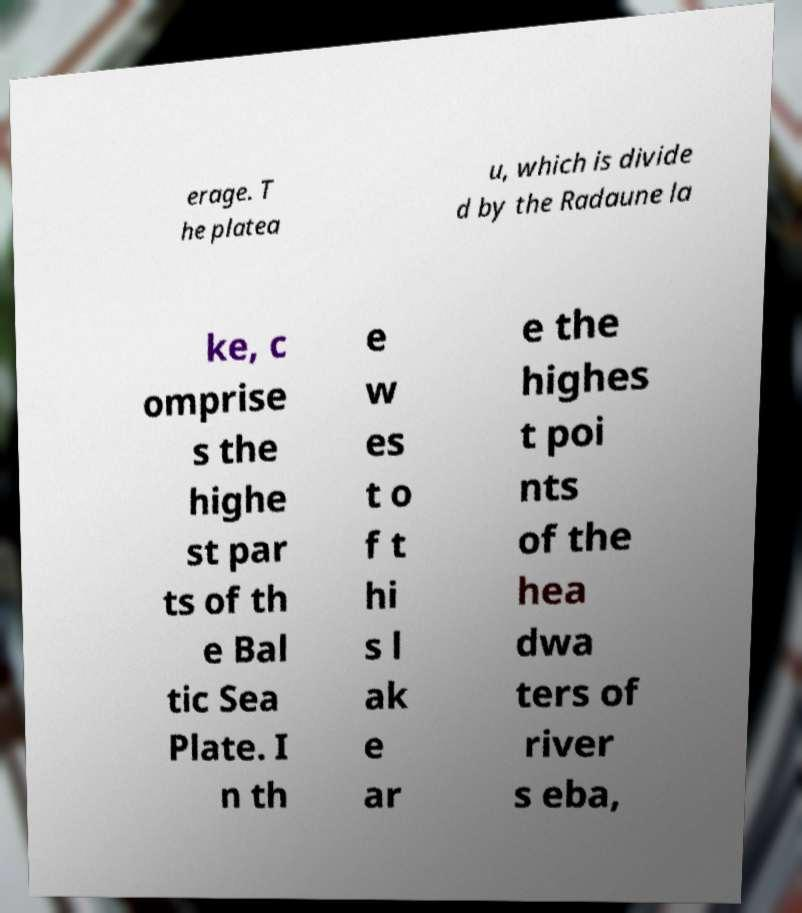Could you extract and type out the text from this image? erage. T he platea u, which is divide d by the Radaune la ke, c omprise s the highe st par ts of th e Bal tic Sea Plate. I n th e w es t o f t hi s l ak e ar e the highes t poi nts of the hea dwa ters of river s eba, 